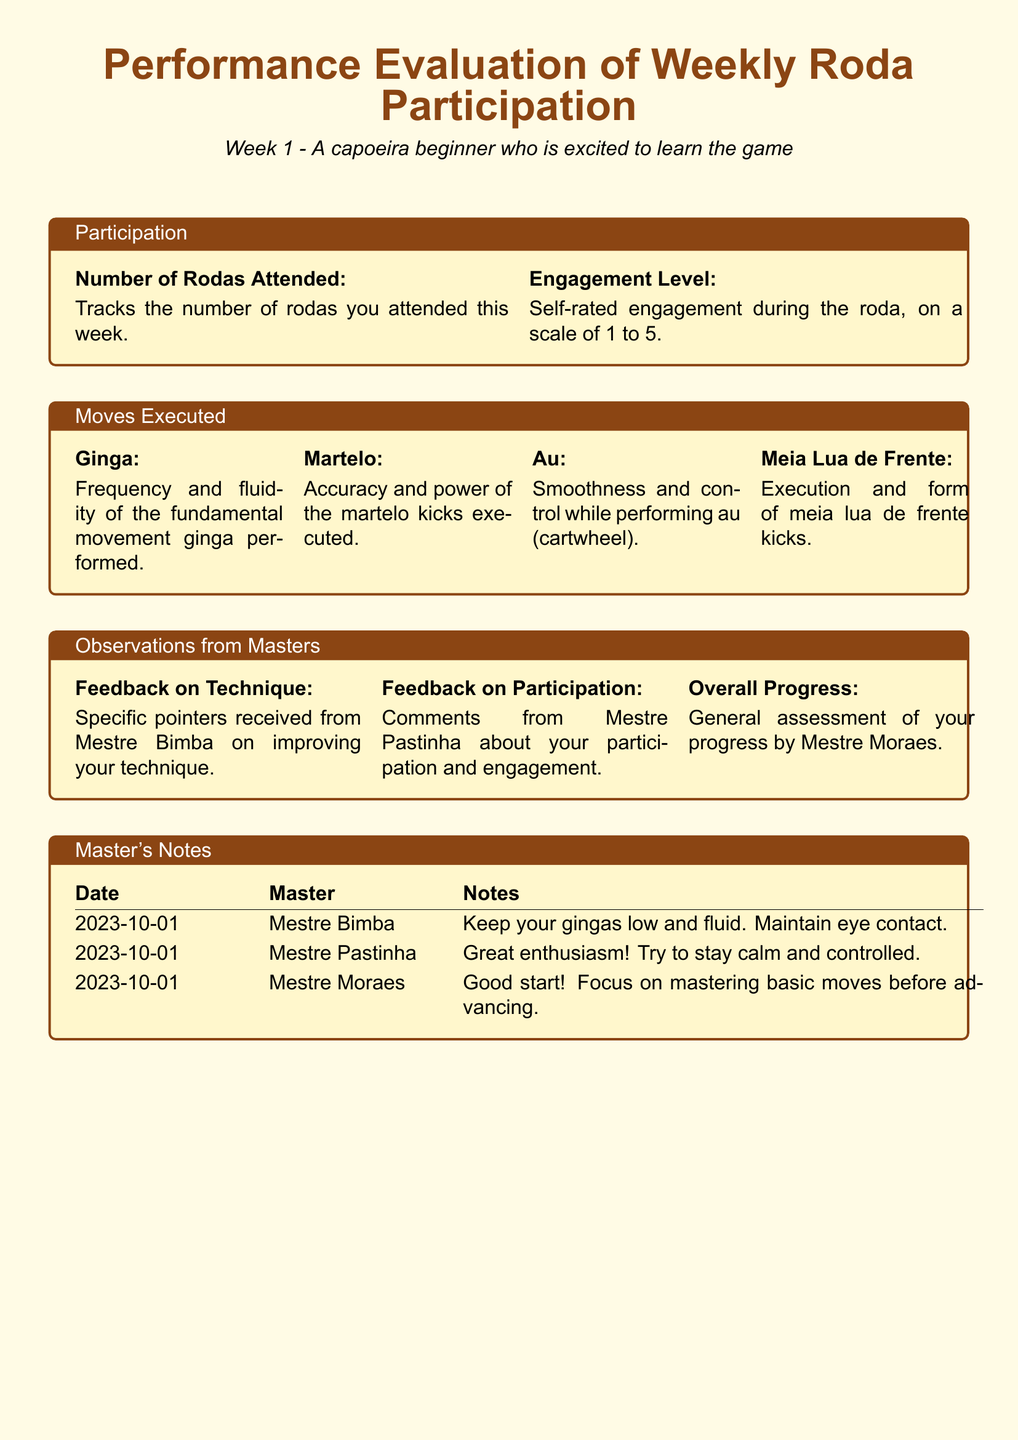How many rodas did you attend this week? The document indicates the number of rodas attended is tracked in the participation section.
Answer: Number of Rodas Attended: What is the self-rated engagement level? The document provides a scale of 1 to 5 for self-rated engagement during the roda.
Answer: Engagement Level: What feedback did Mestre Bimba give about technique? The notes section includes specific feedback on technique from different masters.
Answer: Keep your gingas low and fluid. Maintain eye contact Which move did Mestre Pastinha highlight in his feedback? The feedback from Mestre Pastinha is related to participation and enthusiasm, specifically mentioning staying calm and controlled.
Answer: Great enthusiasm! Try to stay calm and controlled What was Mestre Moraes's general assessment of progress? Mestre Moraes provided an overall progress assessment emphasizing mastery of basic moves.
Answer: Good start! Focus on mastering basic moves before advancing 